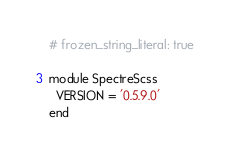Convert code to text. <code><loc_0><loc_0><loc_500><loc_500><_Ruby_># frozen_string_literal: true

module SpectreScss
  VERSION = '0.5.9.0'
end
</code> 